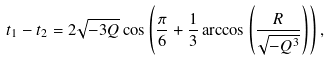Convert formula to latex. <formula><loc_0><loc_0><loc_500><loc_500>t _ { 1 } - t _ { 2 } = 2 \sqrt { - 3 Q } \cos \left ( \frac { \pi } { 6 } + \frac { 1 } { 3 } \arccos \left ( \frac { R } { \sqrt { - Q ^ { 3 } } } \right ) \right ) ,</formula> 